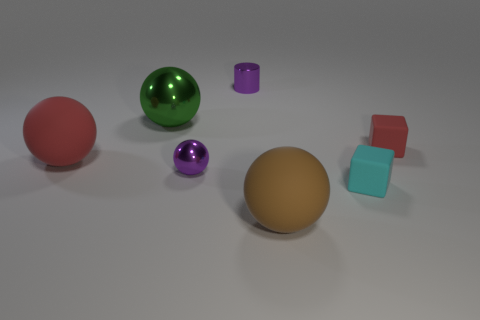Do the block that is behind the purple sphere and the small purple ball have the same size?
Make the answer very short. Yes. What number of cyan objects are rubber things or metal cylinders?
Provide a succinct answer. 1. What is the red object to the right of the brown rubber ball made of?
Provide a succinct answer. Rubber. There is a large rubber object right of the small shiny cylinder; what number of tiny purple cylinders are behind it?
Provide a short and direct response. 1. What number of big brown matte things have the same shape as the small cyan rubber thing?
Provide a short and direct response. 0. What number of brown rubber objects are there?
Ensure brevity in your answer.  1. What is the color of the thing that is in front of the cyan cube?
Keep it short and to the point. Brown. What is the color of the matte ball to the right of the metal sphere that is in front of the big green metal object?
Offer a very short reply. Brown. There is a metallic object that is the same size as the red ball; what is its color?
Offer a very short reply. Green. How many balls are on the right side of the large green ball and on the left side of the big metallic sphere?
Offer a very short reply. 0. 